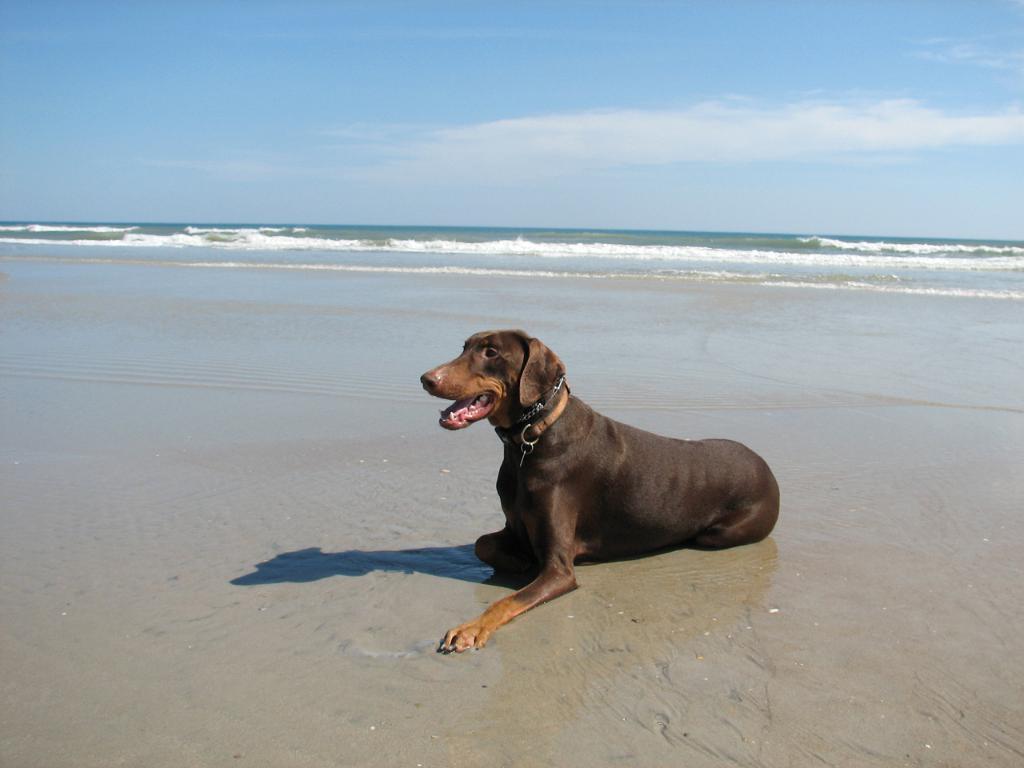Can you describe this image briefly? In this image at front there is a dog. At the back side there is a river and at the top there is sky. 